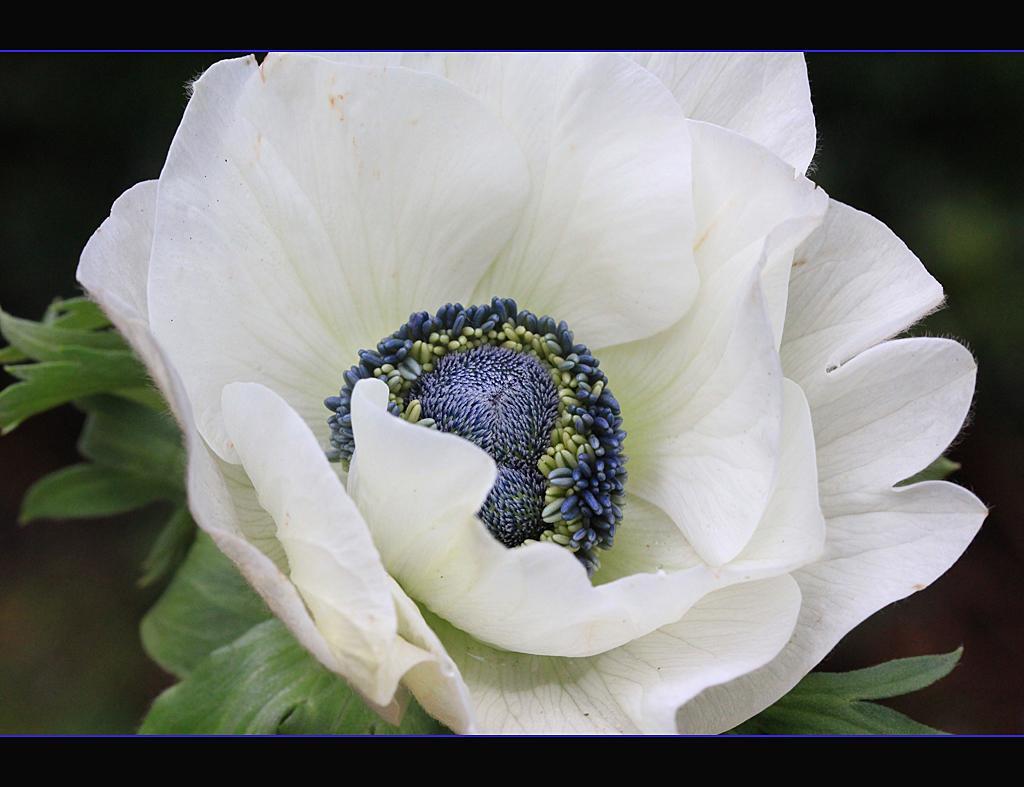Could you give a brief overview of what you see in this image? This is a photo. In the center of the image we can see a flower. In the background, the image is blurred. 